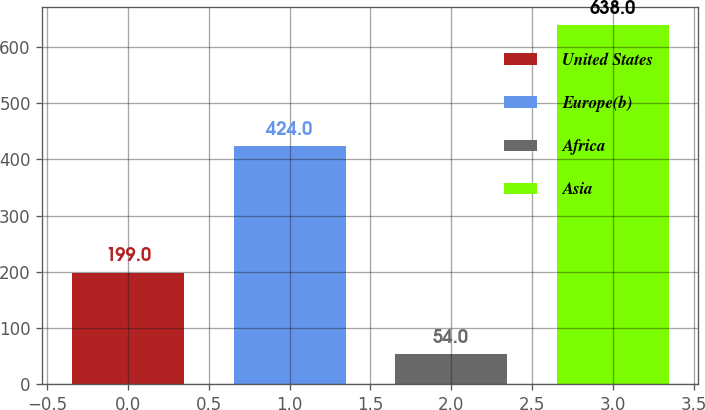Convert chart to OTSL. <chart><loc_0><loc_0><loc_500><loc_500><bar_chart><fcel>United States<fcel>Europe(b)<fcel>Africa<fcel>Asia<nl><fcel>199<fcel>424<fcel>54<fcel>638<nl></chart> 